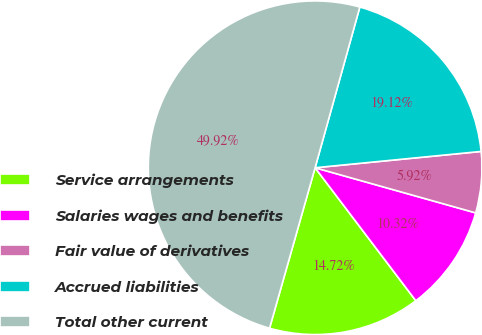Convert chart to OTSL. <chart><loc_0><loc_0><loc_500><loc_500><pie_chart><fcel>Service arrangements<fcel>Salaries wages and benefits<fcel>Fair value of derivatives<fcel>Accrued liabilities<fcel>Total other current<nl><fcel>14.72%<fcel>10.32%<fcel>5.92%<fcel>19.12%<fcel>49.92%<nl></chart> 